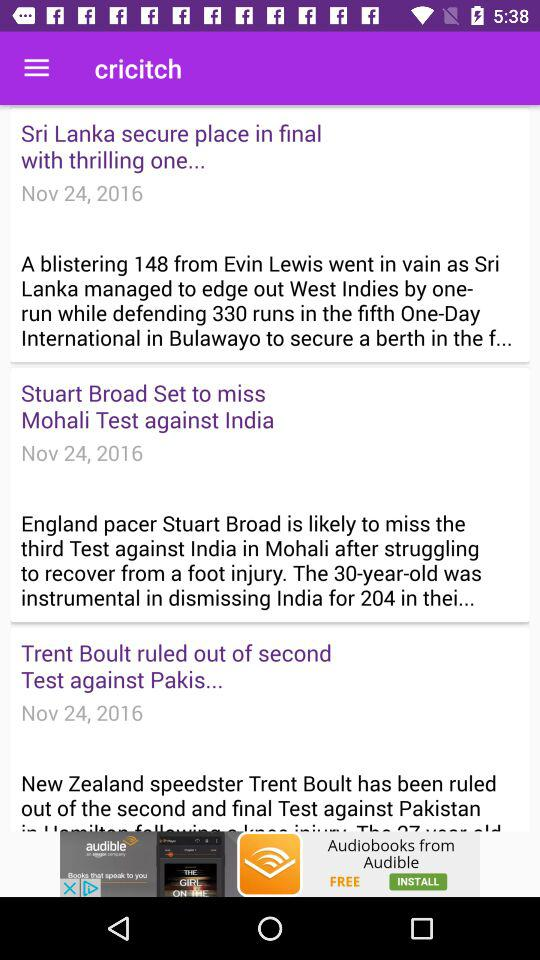What is the score of "Pakistan" in the first and second innings? The score of "Pakistan" in the first and second innings is 216/10 and 230/10, respectively. 